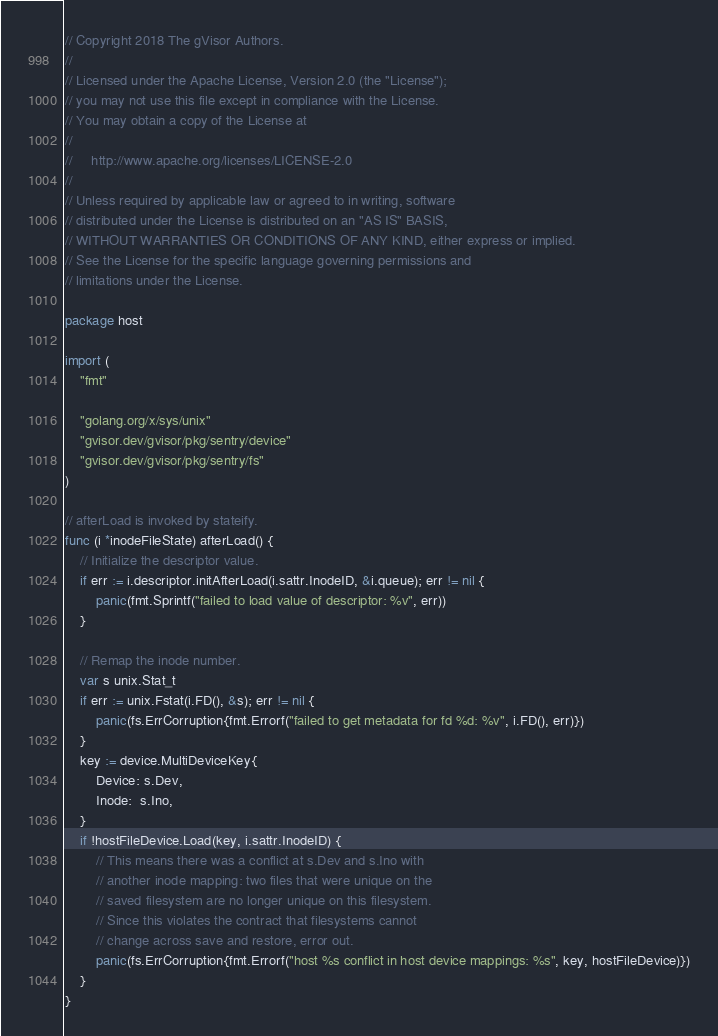Convert code to text. <code><loc_0><loc_0><loc_500><loc_500><_Go_>// Copyright 2018 The gVisor Authors.
//
// Licensed under the Apache License, Version 2.0 (the "License");
// you may not use this file except in compliance with the License.
// You may obtain a copy of the License at
//
//     http://www.apache.org/licenses/LICENSE-2.0
//
// Unless required by applicable law or agreed to in writing, software
// distributed under the License is distributed on an "AS IS" BASIS,
// WITHOUT WARRANTIES OR CONDITIONS OF ANY KIND, either express or implied.
// See the License for the specific language governing permissions and
// limitations under the License.

package host

import (
	"fmt"

	"golang.org/x/sys/unix"
	"gvisor.dev/gvisor/pkg/sentry/device"
	"gvisor.dev/gvisor/pkg/sentry/fs"
)

// afterLoad is invoked by stateify.
func (i *inodeFileState) afterLoad() {
	// Initialize the descriptor value.
	if err := i.descriptor.initAfterLoad(i.sattr.InodeID, &i.queue); err != nil {
		panic(fmt.Sprintf("failed to load value of descriptor: %v", err))
	}

	// Remap the inode number.
	var s unix.Stat_t
	if err := unix.Fstat(i.FD(), &s); err != nil {
		panic(fs.ErrCorruption{fmt.Errorf("failed to get metadata for fd %d: %v", i.FD(), err)})
	}
	key := device.MultiDeviceKey{
		Device: s.Dev,
		Inode:  s.Ino,
	}
	if !hostFileDevice.Load(key, i.sattr.InodeID) {
		// This means there was a conflict at s.Dev and s.Ino with
		// another inode mapping: two files that were unique on the
		// saved filesystem are no longer unique on this filesystem.
		// Since this violates the contract that filesystems cannot
		// change across save and restore, error out.
		panic(fs.ErrCorruption{fmt.Errorf("host %s conflict in host device mappings: %s", key, hostFileDevice)})
	}
}
</code> 